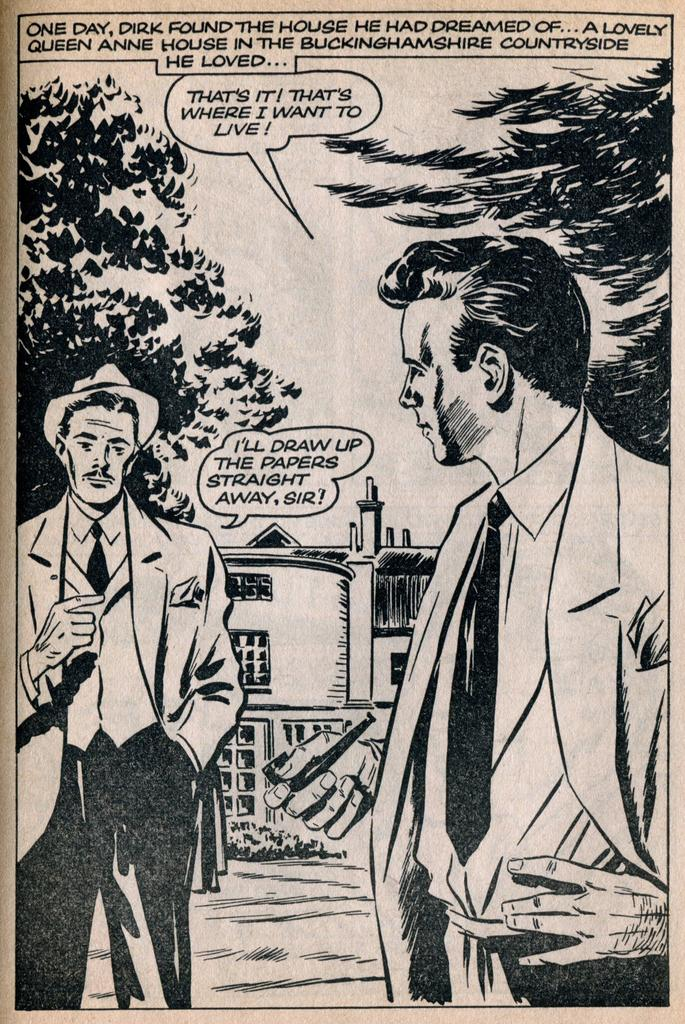What type of visual is the image? The image is a poster. What subjects are depicted on the poster? There are people, trees, and a building depicted on the poster. Is there any text present on the poster? Yes, there is text present on the poster. How many clovers are visible on the poster? There are no clovers depicted on the poster. What type of meeting is taking place in the image? There is no meeting depicted in the image; it is a poster with people, trees, a building, and text. 